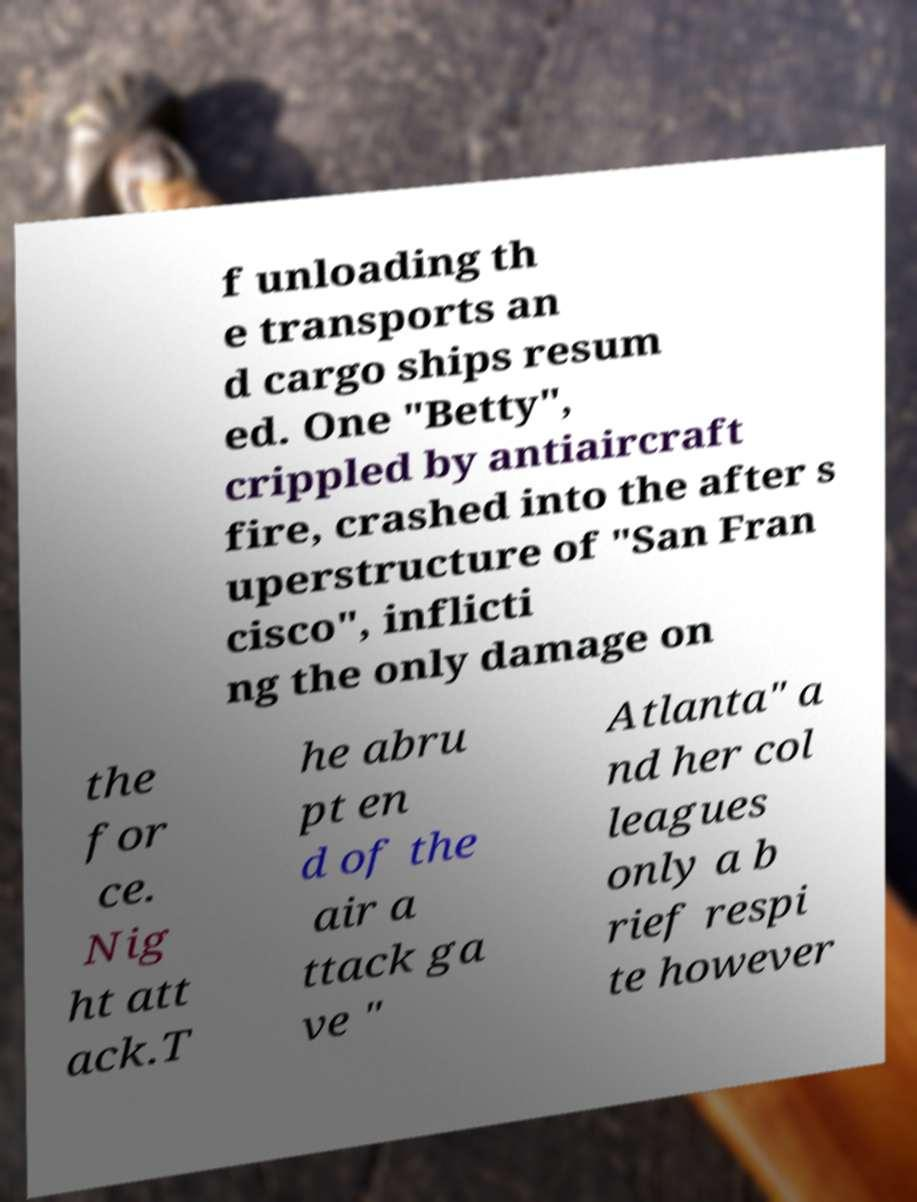Could you extract and type out the text from this image? f unloading th e transports an d cargo ships resum ed. One "Betty", crippled by antiaircraft fire, crashed into the after s uperstructure of "San Fran cisco", inflicti ng the only damage on the for ce. Nig ht att ack.T he abru pt en d of the air a ttack ga ve " Atlanta" a nd her col leagues only a b rief respi te however 